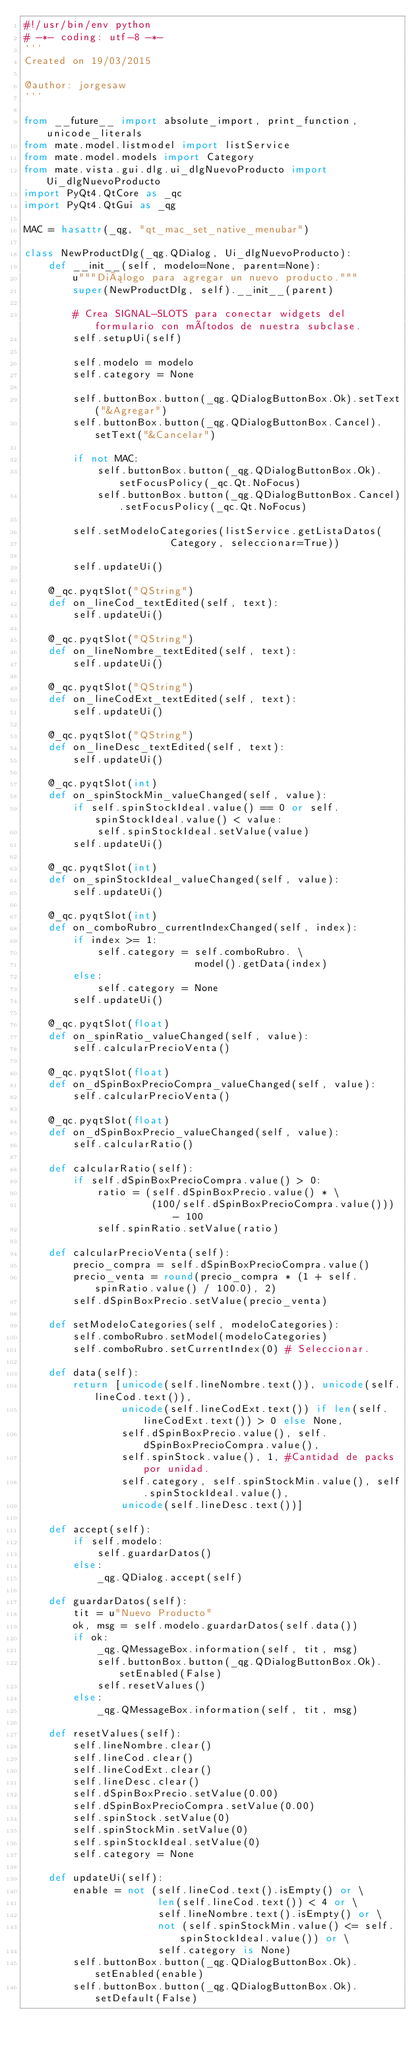<code> <loc_0><loc_0><loc_500><loc_500><_Python_>#!/usr/bin/env python
# -*- coding: utf-8 -*-
'''
Created on 19/03/2015

@author: jorgesaw
'''

from __future__ import absolute_import, print_function, unicode_literals
from mate.model.listmodel import listService
from mate.model.models import Category
from mate.vista.gui.dlg.ui_dlgNuevoProducto import Ui_dlgNuevoProducto
import PyQt4.QtCore as _qc
import PyQt4.QtGui as _qg

MAC = hasattr(_qg, "qt_mac_set_native_menubar")

class NewProductDlg(_qg.QDialog, Ui_dlgNuevoProducto):
    def __init__(self, modelo=None, parent=None):
        u"""Diálogo para agregar un nuevo producto."""
        super(NewProductDlg, self).__init__(parent)

        # Crea SIGNAL-SLOTS para conectar widgets del formulario con métodos de nuestra subclase.
        self.setupUi(self)
        
        self.modelo = modelo
        self.category = None
        
        self.buttonBox.button(_qg.QDialogButtonBox.Ok).setText("&Agregar")
        self.buttonBox.button(_qg.QDialogButtonBox.Cancel).setText("&Cancelar")
        
        if not MAC: 
            self.buttonBox.button(_qg.QDialogButtonBox.Ok).setFocusPolicy(_qc.Qt.NoFocus)
            self.buttonBox.button(_qg.QDialogButtonBox.Cancel).setFocusPolicy(_qc.Qt.NoFocus)
            
        self.setModeloCategories(listService.getListaDatos(
                        Category, seleccionar=True))
        
        self.updateUi()
        
    @_qc.pyqtSlot("QString")
    def on_lineCod_textEdited(self, text):
        self.updateUi()
        
    @_qc.pyqtSlot("QString")
    def on_lineNombre_textEdited(self, text):
        self.updateUi()
        
    @_qc.pyqtSlot("QString")
    def on_lineCodExt_textEdited(self, text):
        self.updateUi()
        
    @_qc.pyqtSlot("QString")
    def on_lineDesc_textEdited(self, text):
        self.updateUi()
        
    @_qc.pyqtSlot(int)
    def on_spinStockMin_valueChanged(self, value):
        if self.spinStockIdeal.value() == 0 or self.spinStockIdeal.value() < value:
            self.spinStockIdeal.setValue(value)
        self.updateUi()
        
    @_qc.pyqtSlot(int)
    def on_spinStockIdeal_valueChanged(self, value):
        self.updateUi()
        
    @_qc.pyqtSlot(int)
    def on_comboRubro_currentIndexChanged(self, index):
        if index >= 1:
            self.category = self.comboRubro. \
                            model().getData(index)
        else:
            self.category = None
        self.updateUi()

    @_qc.pyqtSlot(float)
    def on_spinRatio_valueChanged(self, value):
        self.calcularPrecioVenta()
    
    @_qc.pyqtSlot(float)
    def on_dSpinBoxPrecioCompra_valueChanged(self, value):
        self.calcularPrecioVenta()
    
    @_qc.pyqtSlot(float)
    def on_dSpinBoxPrecio_valueChanged(self, value):
        self.calcularRatio()
    
    def calcularRatio(self):
        if self.dSpinBoxPrecioCompra.value() > 0:
            ratio = (self.dSpinBoxPrecio.value() * \
                     (100/self.dSpinBoxPrecioCompra.value())) - 100
            self.spinRatio.setValue(ratio)
                
    def calcularPrecioVenta(self):
        precio_compra = self.dSpinBoxPrecioCompra.value()
        precio_venta = round(precio_compra * (1 + self.spinRatio.value() / 100.0), 2)
        self.dSpinBoxPrecio.setValue(precio_venta)
                                    
    def setModeloCategories(self, modeloCategories):
        self.comboRubro.setModel(modeloCategories)
        self.comboRubro.setCurrentIndex(0) # Seleccionar.
        
    def data(self):
        return [unicode(self.lineNombre.text()), unicode(self.lineCod.text()),
                unicode(self.lineCodExt.text()) if len(self.lineCodExt.text()) > 0 else None, 
                self.dSpinBoxPrecio.value(), self.dSpinBoxPrecioCompra.value(),   
                self.spinStock.value(), 1, #Cantidad de packs por unidad. 
                self.category, self.spinStockMin.value(), self.spinStockIdeal.value(), 
                unicode(self.lineDesc.text())]
        
    def accept(self):
        if self.modelo:
            self.guardarDatos()
        else:
            _qg.QDialog.accept(self)
            
    def guardarDatos(self):
        tit = u"Nuevo Producto"
        ok, msg = self.modelo.guardarDatos(self.data())
        if ok:
            _qg.QMessageBox.information(self, tit, msg)
            self.buttonBox.button(_qg.QDialogButtonBox.Ok).setEnabled(False)
            self.resetValues()
        else:
            _qg.QMessageBox.information(self, tit, msg)
        
    def resetValues(self):
        self.lineNombre.clear()
        self.lineCod.clear()
        self.lineCodExt.clear()
        self.lineDesc.clear()
        self.dSpinBoxPrecio.setValue(0.00)
        self.dSpinBoxPrecioCompra.setValue(0.00)
        self.spinStock.setValue(0)
        self.spinStockMin.setValue(0)
        self.spinStockIdeal.setValue(0)
        self.category = None
        
    def updateUi(self):
        enable = not (self.lineCod.text().isEmpty() or \
                      len(self.lineCod.text()) < 4 or \
                      self.lineNombre.text().isEmpty() or \
                      not (self.spinStockMin.value() <= self.spinStockIdeal.value()) or \
                      self.category is None)
        self.buttonBox.button(_qg.QDialogButtonBox.Ok).setEnabled(enable)
        self.buttonBox.button(_qg.QDialogButtonBox.Ok).setDefault(False)</code> 